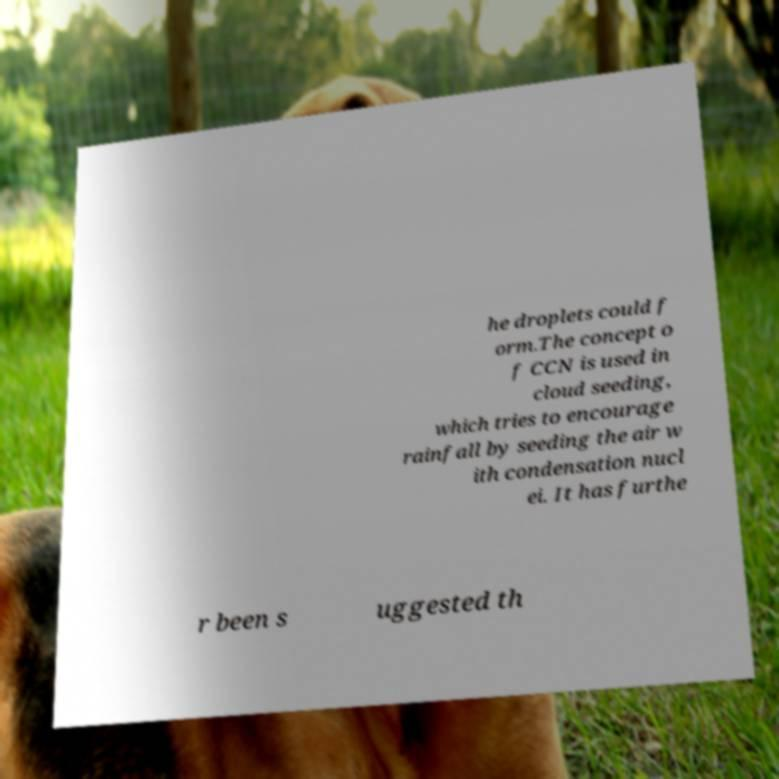Could you assist in decoding the text presented in this image and type it out clearly? he droplets could f orm.The concept o f CCN is used in cloud seeding, which tries to encourage rainfall by seeding the air w ith condensation nucl ei. It has furthe r been s uggested th 